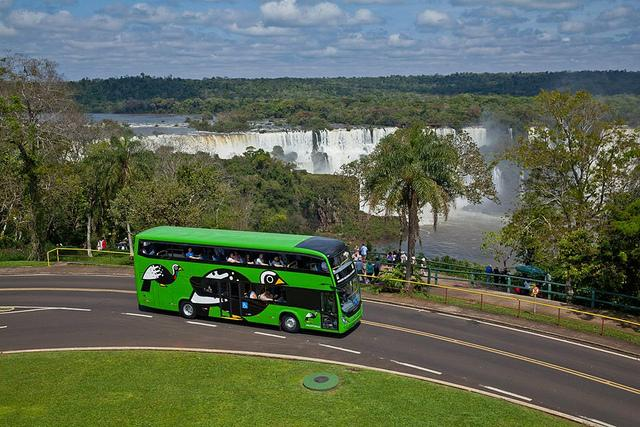Where are the people on the bus going? destination 